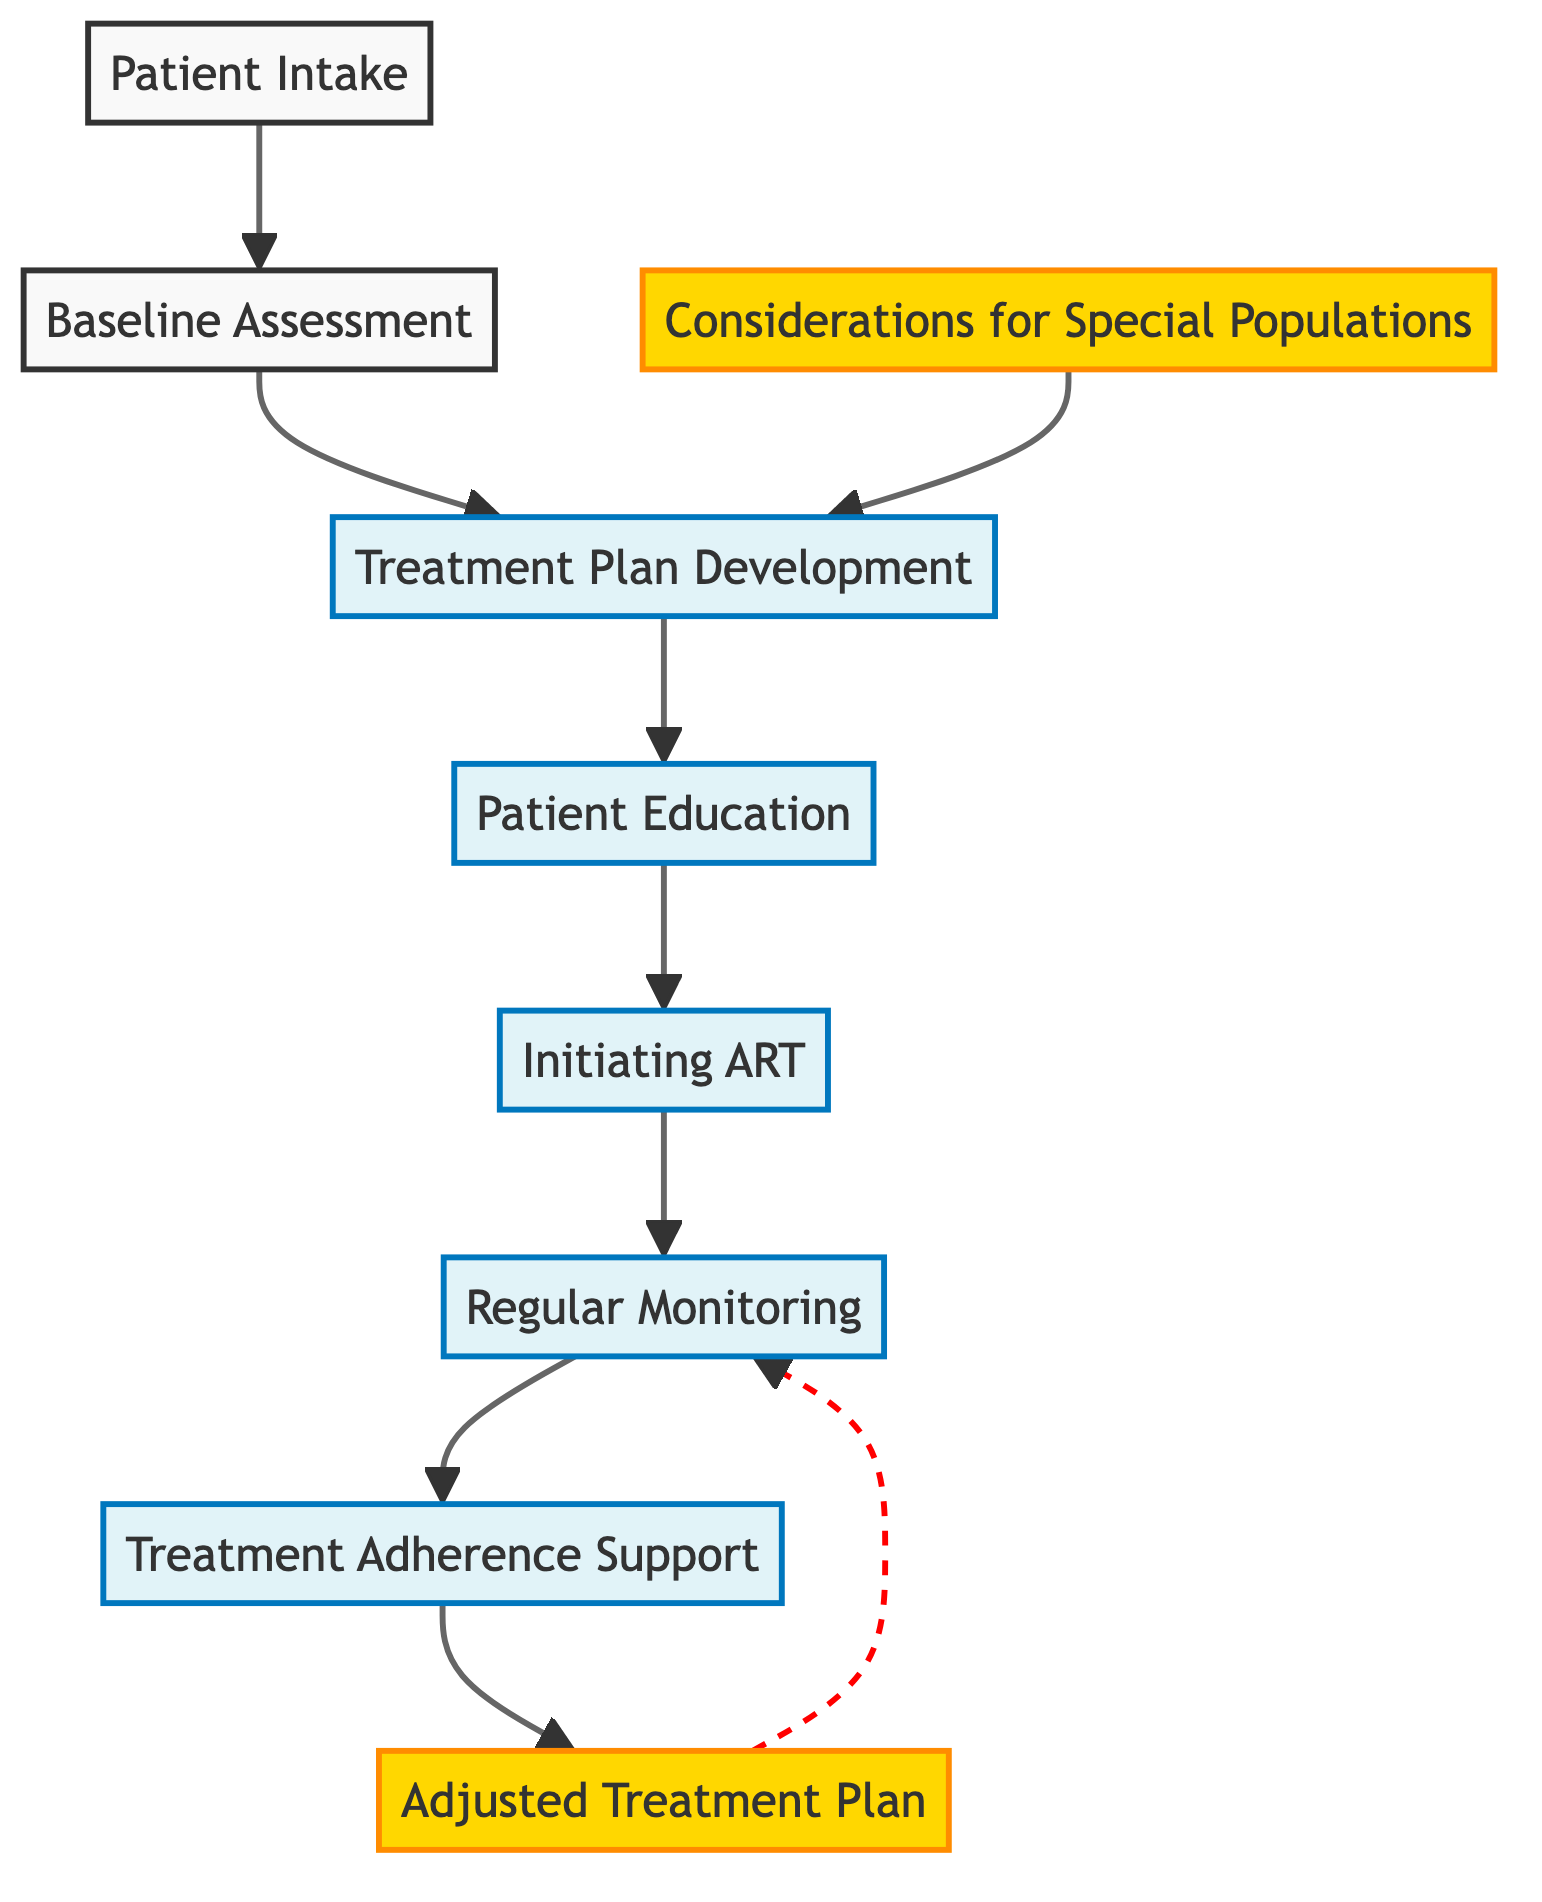What is the first step in the HIV treatment plan development process? The first step in the flow chart is "Patient Intake," where the collection of patient medical history, lifestyle, and HIV status occurs.
Answer: Patient Intake How many connections are there from "Regular Monitoring"? "Regular Monitoring" has two connections; one leading to "Treatment Adherence Support" and another leading back to "Adjusted Treatment Plan."
Answer: 2 What follows after "Patient Education"? "Patient Education" is followed by "Initiating ART" in the flow of the treatment process.
Answer: Initiating ART What is the primary purpose of "Treatment Adherence Support"? The specific goal of "Treatment Adherence Support" is to provide ongoing support through counseling, peer support groups, and addressing barriers to adherence.
Answer: Ongoing support Which element contains considerations for special populations? The element that addresses considerations for special populations is labeled "Considerations for Special Populations." It connects back to "Treatment Plan Development."
Answer: Considerations for Special Populations How does "Adjusted Treatment Plan" relate to "Regular Monitoring"? "Adjusted Treatment Plan" modifies the treatment based on monitoring results and feeds back into "Regular Monitoring" for continued assessment and adjustment.
Answer: Feeds back What happens after "Initiating ART"? After "Initiating ART," the next step is "Regular Monitoring" to ensure effective therapy and manage side effects.
Answer: Regular Monitoring What is the underlying theme connecting "Considerations for Special Populations" and "Treatment Plan Development"? The connection between "Considerations for Special Populations" and "Treatment Plan Development" indicates that tailored approaches inform the development of an individualized treatment plan.
Answer: Tailored approaches What type of diagram is used to represent the HIV treatment plan development and monitoring process? The diagram type used here is a "Flow Chart," which visually describes sequential processes and connections between various elements in the treatment plan.
Answer: Flow Chart 